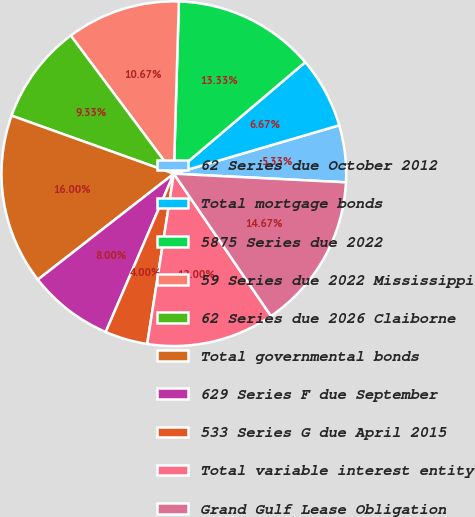Convert chart to OTSL. <chart><loc_0><loc_0><loc_500><loc_500><pie_chart><fcel>62 Series due October 2012<fcel>Total mortgage bonds<fcel>5875 Series due 2022<fcel>59 Series due 2022 Mississippi<fcel>62 Series due 2026 Claiborne<fcel>Total governmental bonds<fcel>629 Series F due September<fcel>533 Series G due April 2015<fcel>Total variable interest entity<fcel>Grand Gulf Lease Obligation<nl><fcel>5.33%<fcel>6.67%<fcel>13.33%<fcel>10.67%<fcel>9.33%<fcel>16.0%<fcel>8.0%<fcel>4.0%<fcel>12.0%<fcel>14.67%<nl></chart> 